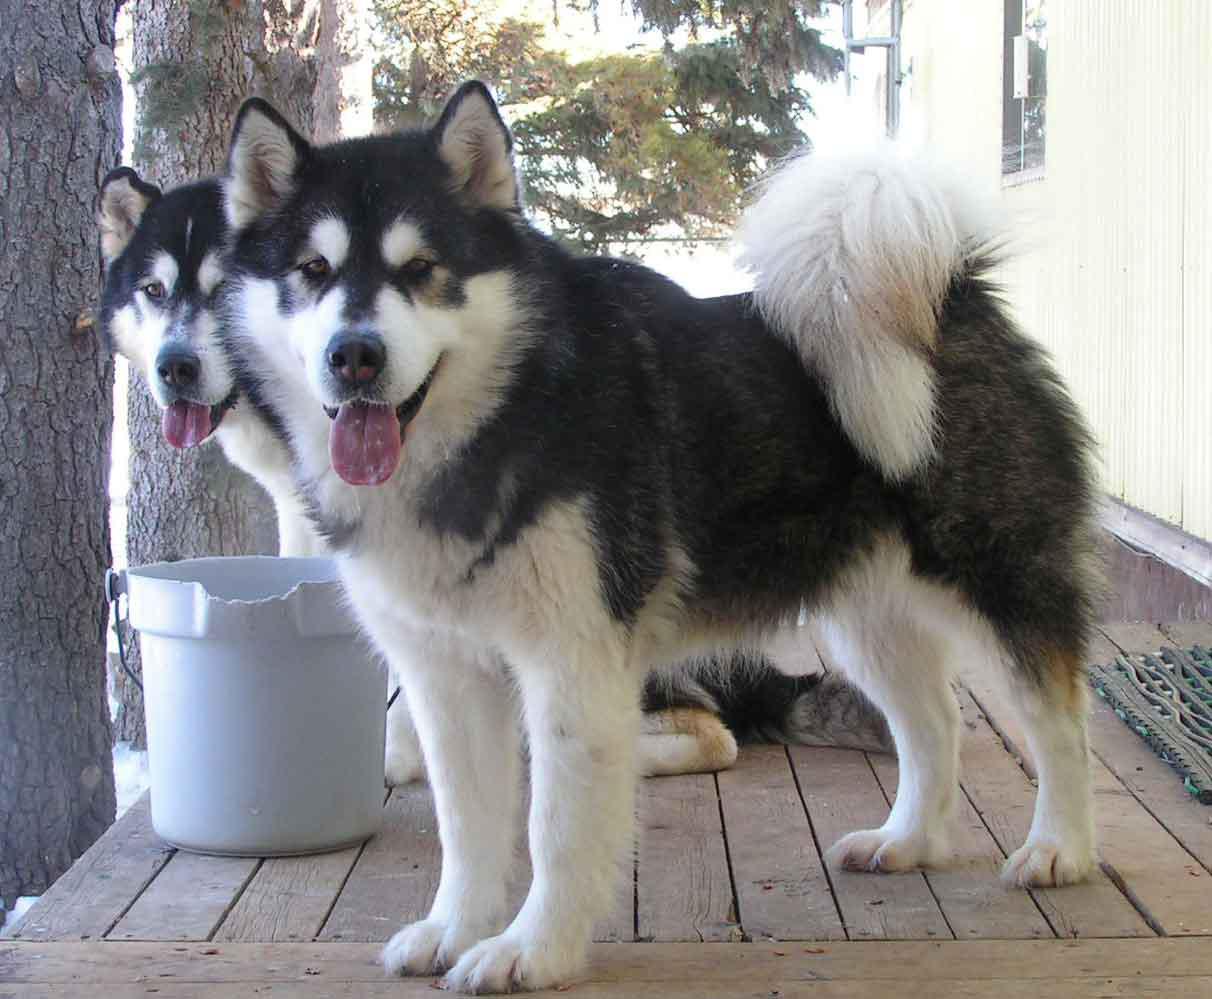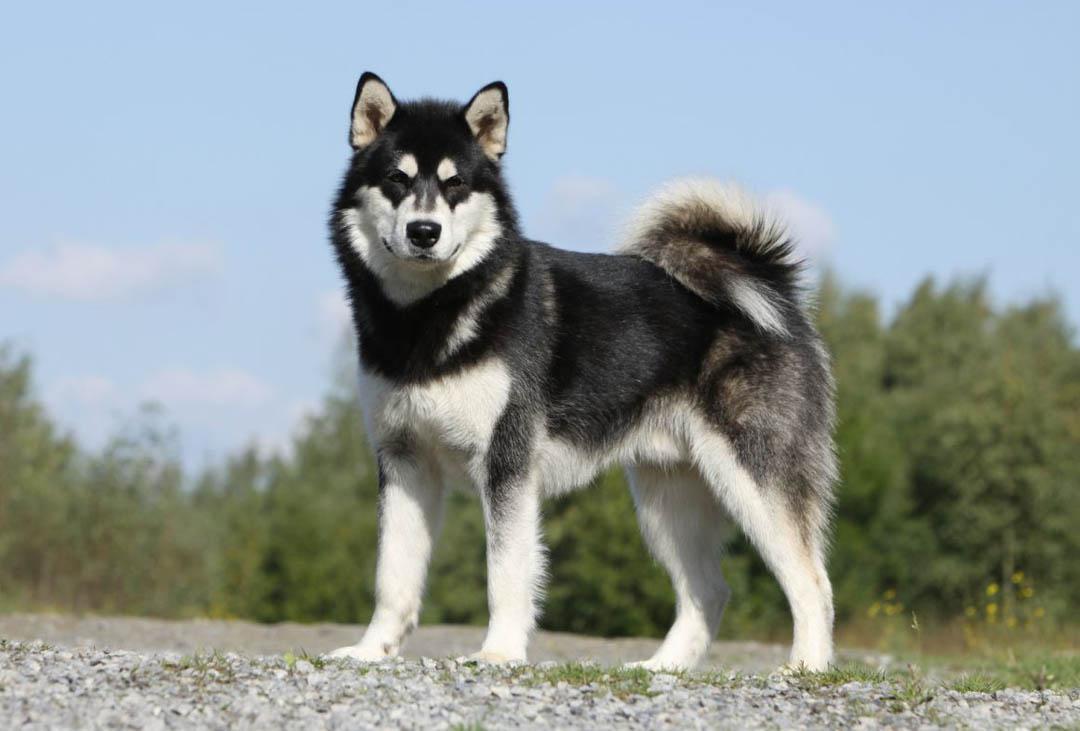The first image is the image on the left, the second image is the image on the right. Considering the images on both sides, is "Each image contains one prominent camera-gazing husky dog with blue eyes and a closed mouth." valid? Answer yes or no. No. The first image is the image on the left, the second image is the image on the right. For the images displayed, is the sentence "There are two dogs with light colored eyes." factually correct? Answer yes or no. No. 